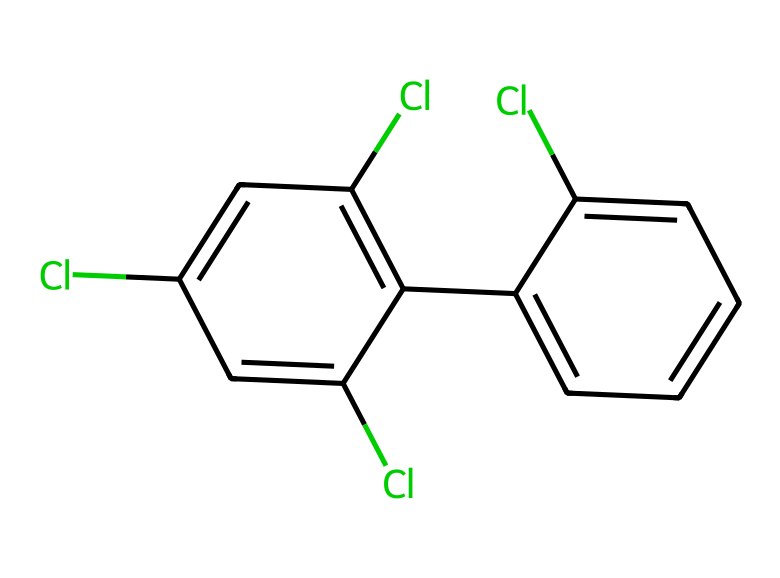How many chlorine atoms are present in this structure? By examining the SMILES representation, we can count the number of 'Cl' notations, which indicate the presence of chlorine atoms. There are four 'Cl' notations in the structure.
Answer: four What type of compound is represented by this SMILES? The given structure represents a polychlorinated biphenyl (PCB), which consists of a biphenyl core with multiple chlorine substitutions.
Answer: polychlorinated biphenyl What is the total number of carbon atoms in this structure? By breaking down the structure, we can identify that there are 12 carbon atoms present, as indicated by the repeating 'c' characters and considering the biphenyl structure.
Answer: twelve Which functional group is primarily associated with the toxicity of this chemical? PCBs are known for their chlorine substituents, which are responsible for their toxic properties. The presence of multiple chlorine atoms indicates a halogenated compound, contributing to its toxicity.
Answer: chlorine How many benzene rings are present in this structure? The structure reveals two interconnected aromatic rings, which are characteristic of biphenyl compounds. We can identify each 'c' cluster as part of a benzene ring.
Answer: two What is the approximate molecular weight of this compound? By calculating the molecular weight from the composition of 12 carbons, 4 chlorines, and 8 hydrogens (C12H8Cl4), the total comes to approximately 257.84 g/mol.
Answer: 257.84 Does this compound exhibit potential environmental hazards? Yes, due to its persistent nature and toxicity to wildlife and humans, primarily resulting from the chlorine atoms that interfere with biological processes.
Answer: yes 